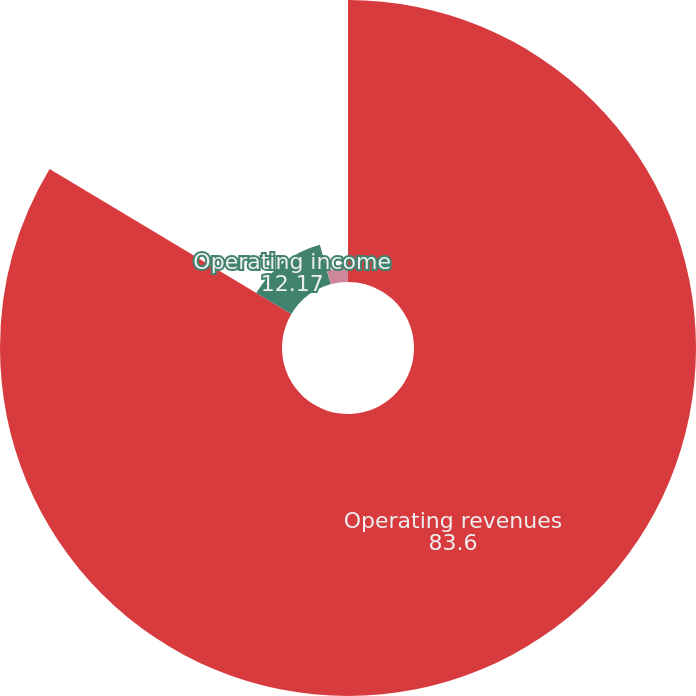<chart> <loc_0><loc_0><loc_500><loc_500><pie_chart><fcel>Operating revenues<fcel>Operating income<fcel>Net income for common stock<nl><fcel>83.6%<fcel>12.17%<fcel>4.23%<nl></chart> 